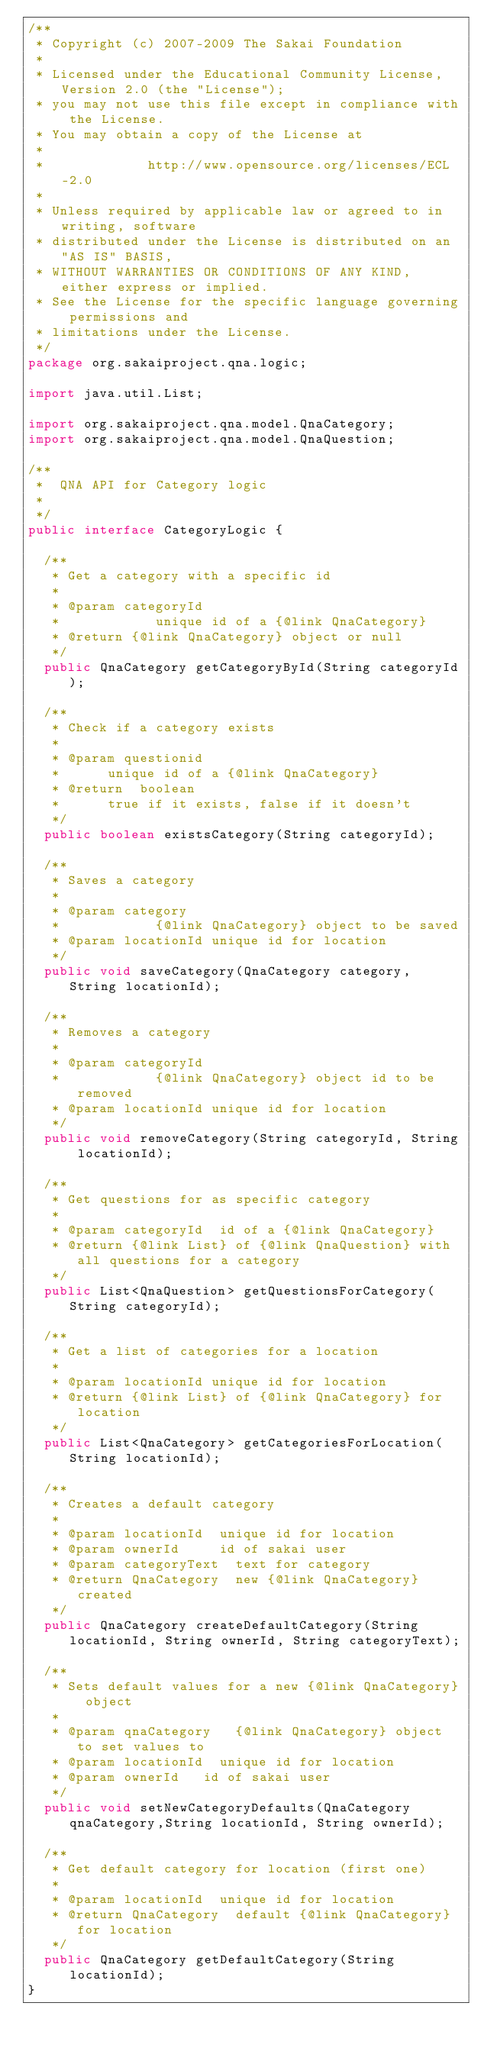Convert code to text. <code><loc_0><loc_0><loc_500><loc_500><_Java_>/**
 * Copyright (c) 2007-2009 The Sakai Foundation
 *
 * Licensed under the Educational Community License, Version 2.0 (the "License");
 * you may not use this file except in compliance with the License.
 * You may obtain a copy of the License at
 *
 *             http://www.opensource.org/licenses/ECL-2.0
 *
 * Unless required by applicable law or agreed to in writing, software
 * distributed under the License is distributed on an "AS IS" BASIS,
 * WITHOUT WARRANTIES OR CONDITIONS OF ANY KIND, either express or implied.
 * See the License for the specific language governing permissions and
 * limitations under the License.
 */
package org.sakaiproject.qna.logic;

import java.util.List;

import org.sakaiproject.qna.model.QnaCategory;
import org.sakaiproject.qna.model.QnaQuestion;

/**
 *	QNA API for Category logic 
 *
 */
public interface CategoryLogic {

	/**
	 * Get a category with a specific id
	 *
	 * @param categoryId
	 *            unique id of a {@link QnaCategory}
	 * @return {@link QnaCategory} object or null
	 */
	public QnaCategory getCategoryById(String categoryId);

	/**
	 * Check if a category exists
	 *
	 * @param questionid
	 * 			unique id of a {@link QnaCategory}
	 * @return	boolean
	 * 			true if it exists, false if it doesn't
	 */
	public boolean existsCategory(String categoryId);

	/**
	 * Saves a category
	 *
	 * @param category
	 *            {@link QnaCategory} object to be saved
	 * @param locationId unique id for location
	 */
	public void saveCategory(QnaCategory category, String locationId);

	/**
	 * Removes a category
	 *
	 * @param categoryId
	 *            {@link QnaCategory} object id to be removed
	 * @param locationId unique id for location
	 */
	public void removeCategory(String categoryId, String locationId);

	/**
	 * Get questions for as specific category
	 *
	 * @param categoryId 	id of a {@link QnaCategory}
	 * @return {@link List} of {@link QnaQuestion} with all questions for a category
	 */
	public List<QnaQuestion> getQuestionsForCategory(String categoryId);

	/**
	 * Get a list of categories for a location
	 *
	 * @param locationId unique id for location
	 * @return {@link List} of {@link QnaCategory} for location
	 */
	public List<QnaCategory> getCategoriesForLocation(String locationId);

	/**
	 * Creates a default category
	 *
	 * @param locationId 	unique id for location
	 * @param ownerId 		id of sakai user
	 * @param categoryText 	text for category
	 * @return QnaCategory 	new {@link QnaCategory} created
	 */
	public QnaCategory createDefaultCategory(String locationId, String ownerId, String categoryText);
	
	/**
	 * Sets default values for a new {@link QnaCategory} object
	 * 
	 * @param qnaCategory 	{@link QnaCategory} object to set values to
	 * @param locationId 	unique id for location
	 * @param ownerId		id of sakai user
	 */
	public void setNewCategoryDefaults(QnaCategory qnaCategory,String locationId, String ownerId);
	
	/**
	 * Get default category for location (first one)
	 * 
	 * @param locationId	unique id for location
	 * @return QnaCategory 	default {@link QnaCategory} for location
	 */
	public QnaCategory getDefaultCategory(String locationId);
}
</code> 